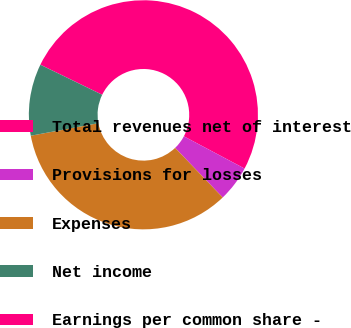<chart> <loc_0><loc_0><loc_500><loc_500><pie_chart><fcel>Total revenues net of interest<fcel>Provisions for losses<fcel>Expenses<fcel>Net income<fcel>Earnings per common share -<nl><fcel>50.56%<fcel>5.06%<fcel>34.24%<fcel>10.12%<fcel>0.01%<nl></chart> 